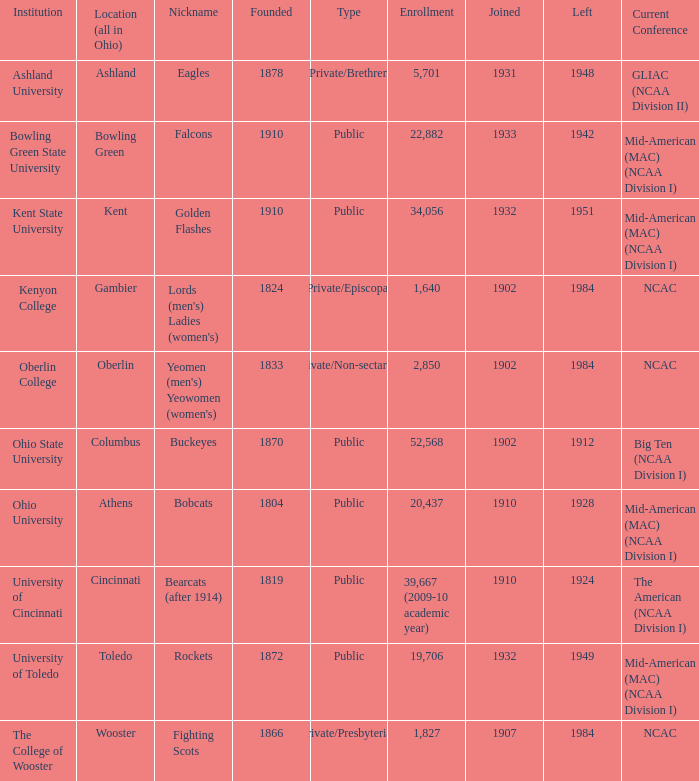Which year did signed-up gambier members exit? 1984.0. 